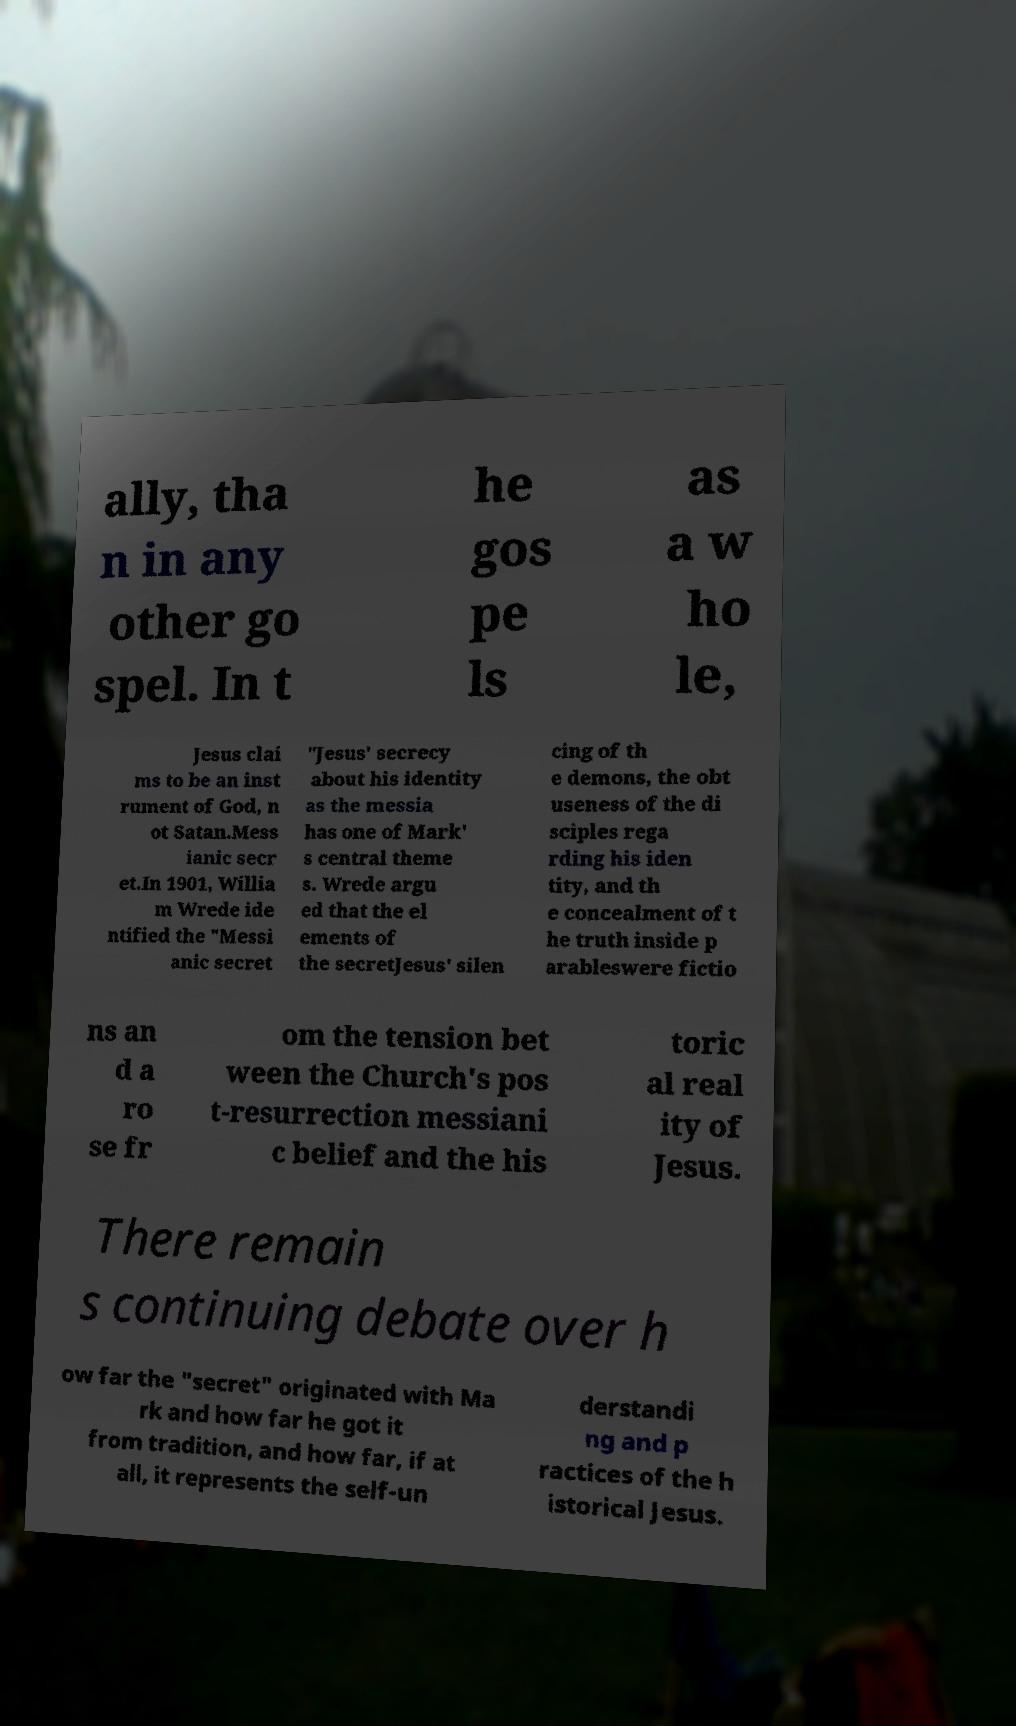I need the written content from this picture converted into text. Can you do that? ally, tha n in any other go spel. In t he gos pe ls as a w ho le, Jesus clai ms to be an inst rument of God, n ot Satan.Mess ianic secr et.In 1901, Willia m Wrede ide ntified the "Messi anic secret "Jesus' secrecy about his identity as the messia has one of Mark' s central theme s. Wrede argu ed that the el ements of the secretJesus' silen cing of th e demons, the obt useness of the di sciples rega rding his iden tity, and th e concealment of t he truth inside p arableswere fictio ns an d a ro se fr om the tension bet ween the Church's pos t-resurrection messiani c belief and the his toric al real ity of Jesus. There remain s continuing debate over h ow far the "secret" originated with Ma rk and how far he got it from tradition, and how far, if at all, it represents the self-un derstandi ng and p ractices of the h istorical Jesus. 